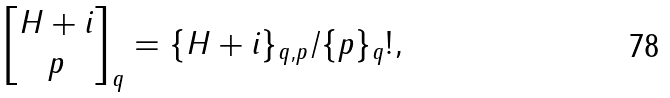Convert formula to latex. <formula><loc_0><loc_0><loc_500><loc_500>\begin{bmatrix} H + i \\ p \end{bmatrix} _ { q } = \{ H + i \} _ { q , p } / \{ p \} _ { q } ! ,</formula> 